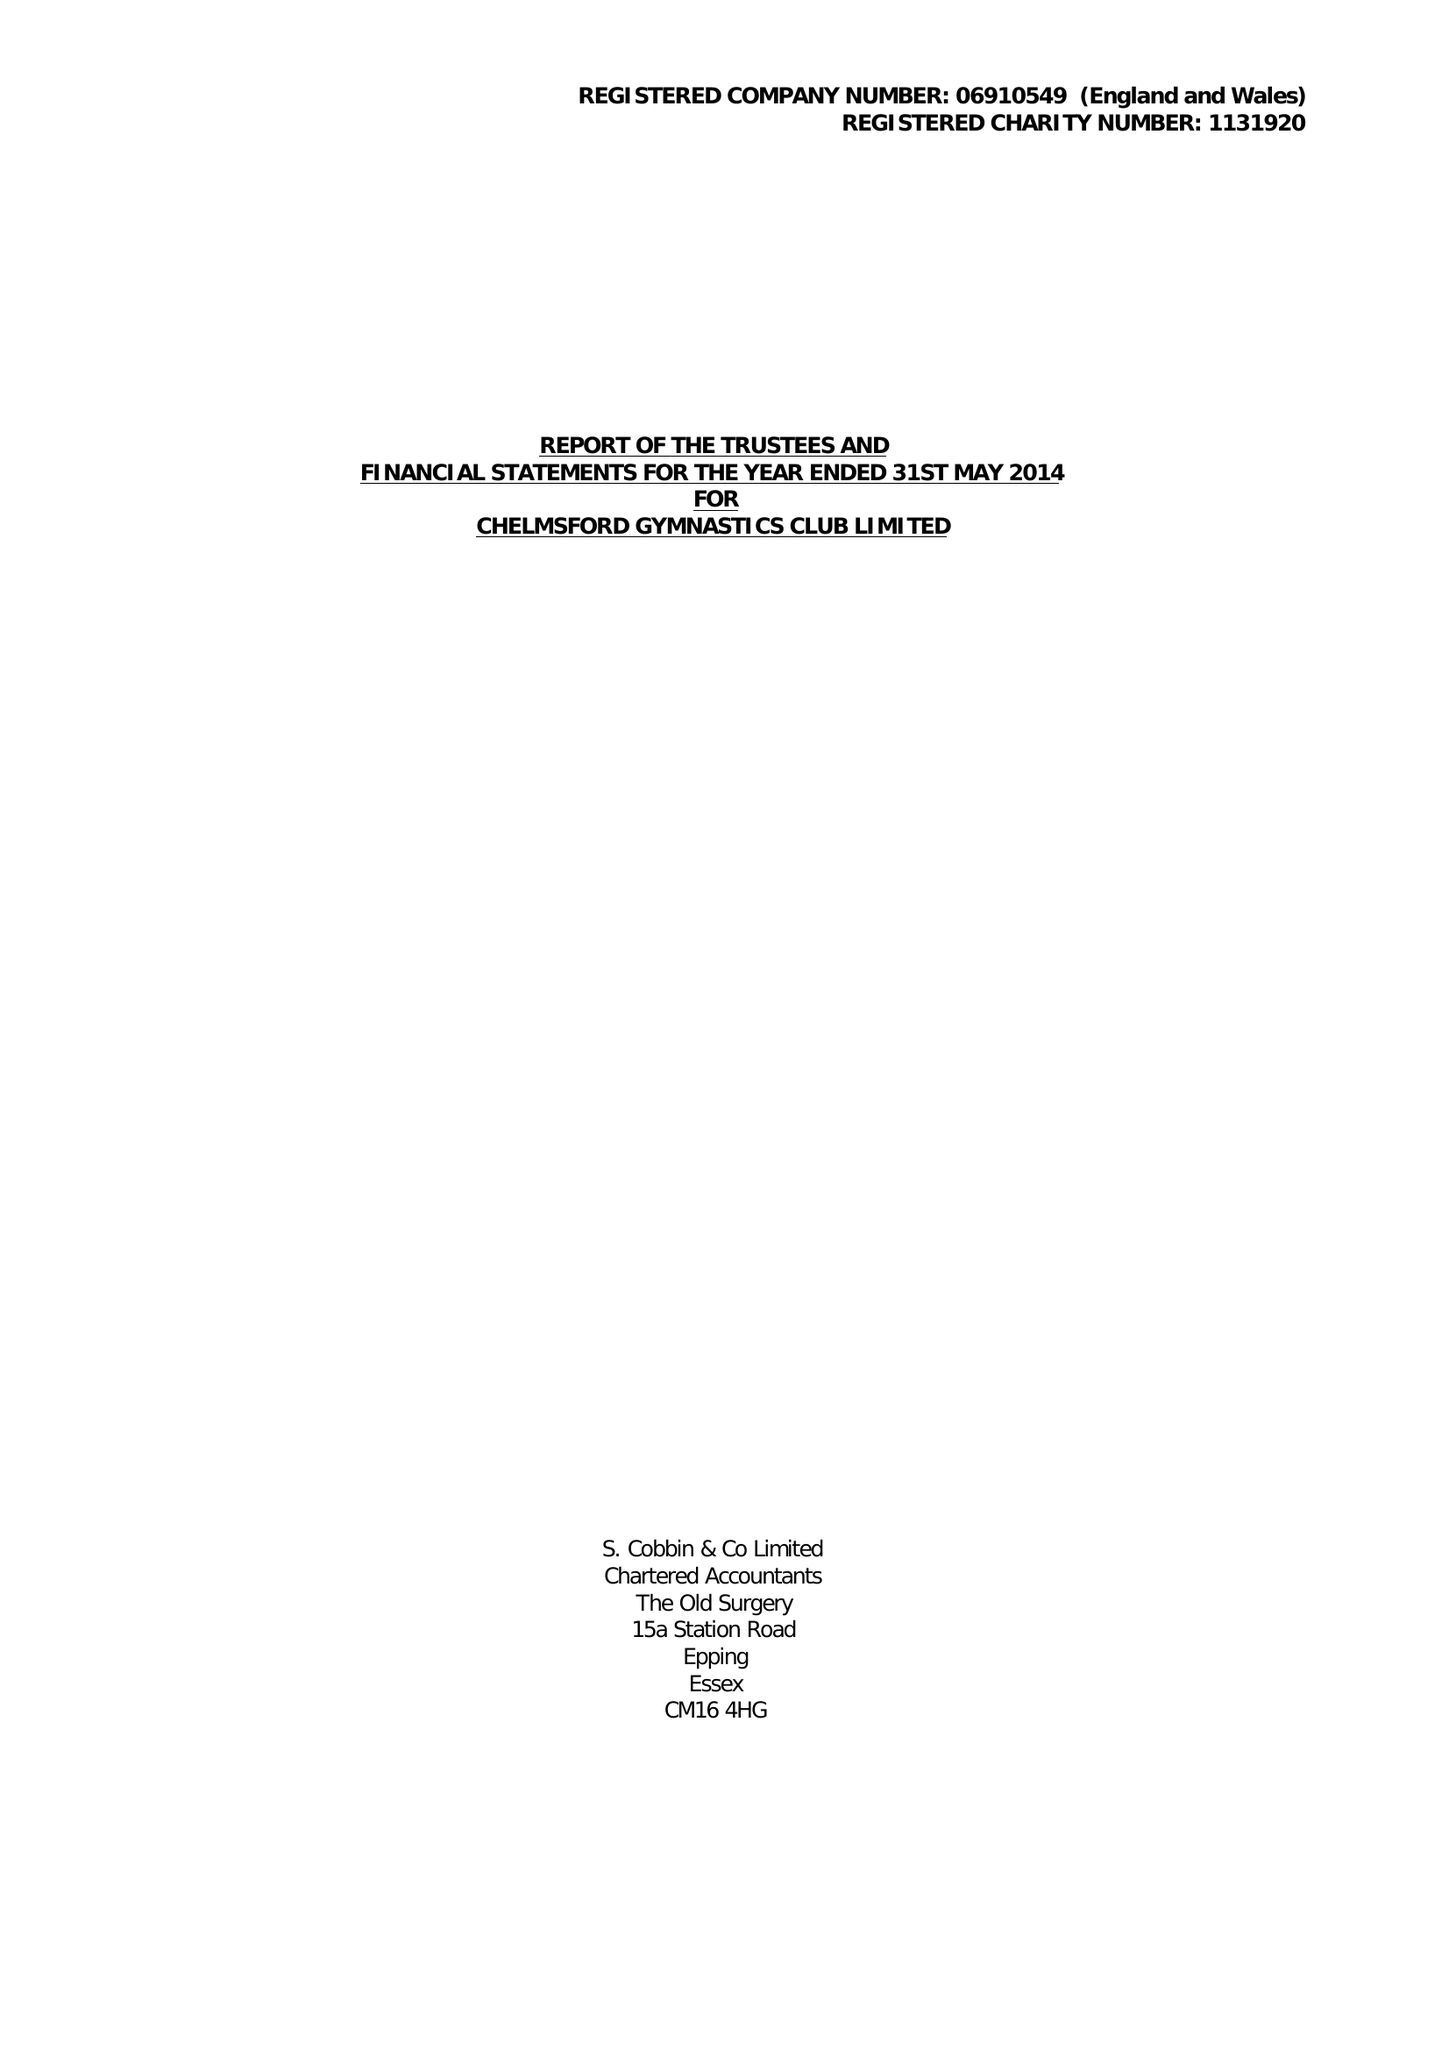What is the value for the income_annually_in_british_pounds?
Answer the question using a single word or phrase. 274567.00 